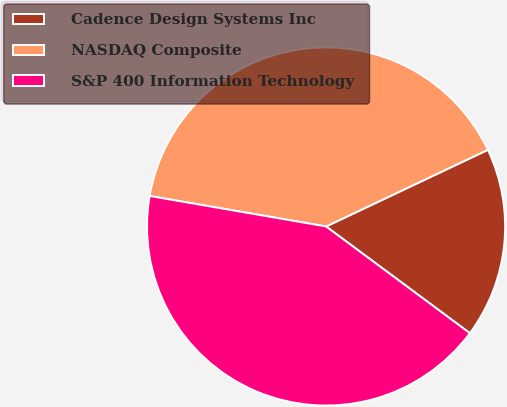Convert chart. <chart><loc_0><loc_0><loc_500><loc_500><pie_chart><fcel>Cadence Design Systems Inc<fcel>NASDAQ Composite<fcel>S&P 400 Information Technology<nl><fcel>17.2%<fcel>40.23%<fcel>42.56%<nl></chart> 